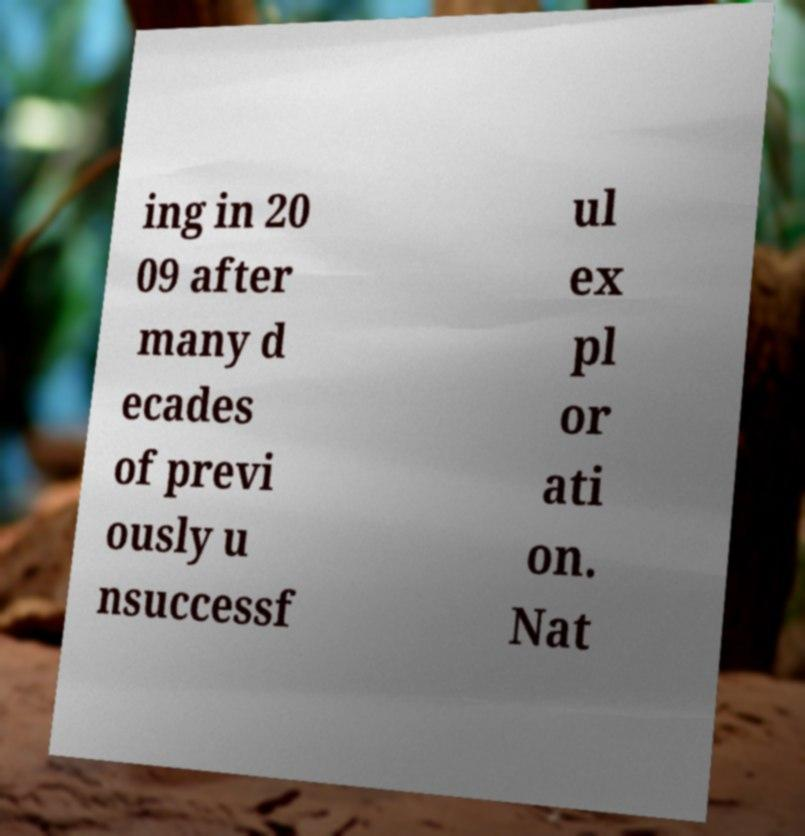For documentation purposes, I need the text within this image transcribed. Could you provide that? ing in 20 09 after many d ecades of previ ously u nsuccessf ul ex pl or ati on. Nat 